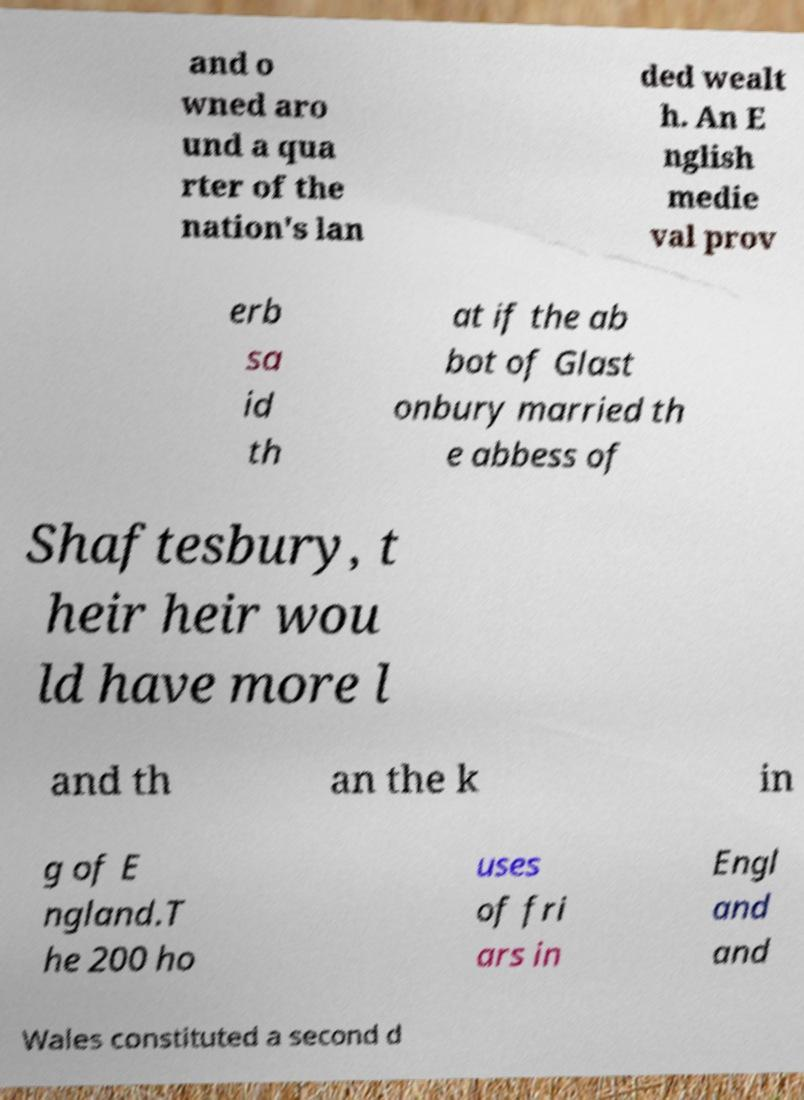Can you accurately transcribe the text from the provided image for me? and o wned aro und a qua rter of the nation's lan ded wealt h. An E nglish medie val prov erb sa id th at if the ab bot of Glast onbury married th e abbess of Shaftesbury, t heir heir wou ld have more l and th an the k in g of E ngland.T he 200 ho uses of fri ars in Engl and and Wales constituted a second d 